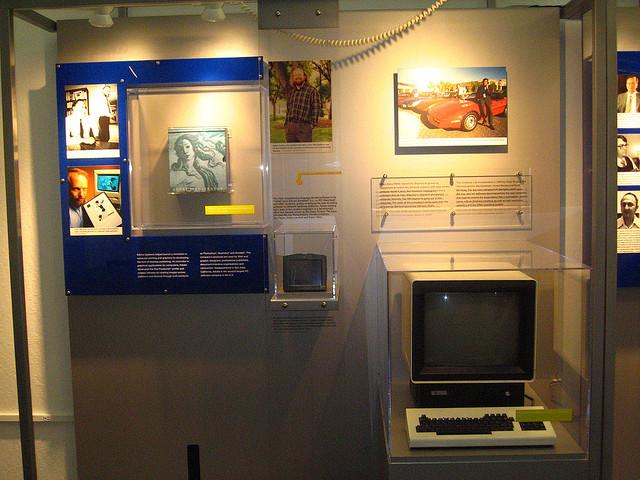What type of cord is shown?
Short answer required. Phone. Is this in a museum?
Quick response, please. Yes. Is the woman a drawing or a picture?
Keep it brief. Drawing. 